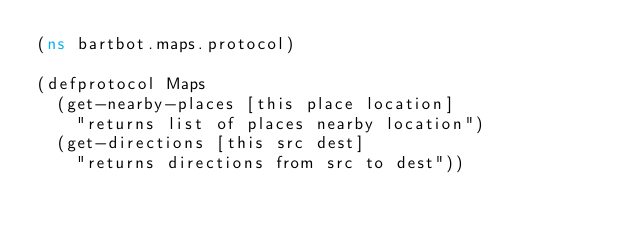Convert code to text. <code><loc_0><loc_0><loc_500><loc_500><_Clojure_>(ns bartbot.maps.protocol)

(defprotocol Maps
  (get-nearby-places [this place location]
    "returns list of places nearby location")
  (get-directions [this src dest]
    "returns directions from src to dest"))
</code> 